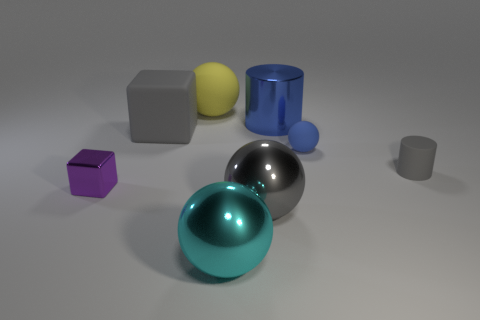How many large objects are either gray shiny balls or cyan objects?
Keep it short and to the point. 2. There is a matte sphere that is in front of the blue cylinder; does it have the same size as the blue cylinder?
Give a very brief answer. No. What number of other things are there of the same color as the big shiny cylinder?
Give a very brief answer. 1. What is the yellow sphere made of?
Give a very brief answer. Rubber. The gray thing that is both on the left side of the tiny sphere and in front of the blue rubber thing is made of what material?
Ensure brevity in your answer.  Metal. What number of objects are balls on the right side of the large gray sphere or blue cylinders?
Provide a short and direct response. 2. Is the metallic cube the same color as the large metal cylinder?
Your answer should be compact. No. Are there any yellow rubber things that have the same size as the gray cylinder?
Give a very brief answer. No. What number of metal objects are both to the left of the big yellow ball and in front of the big gray shiny ball?
Your response must be concise. 0. There is a yellow object; what number of large cylinders are right of it?
Your response must be concise. 1. 